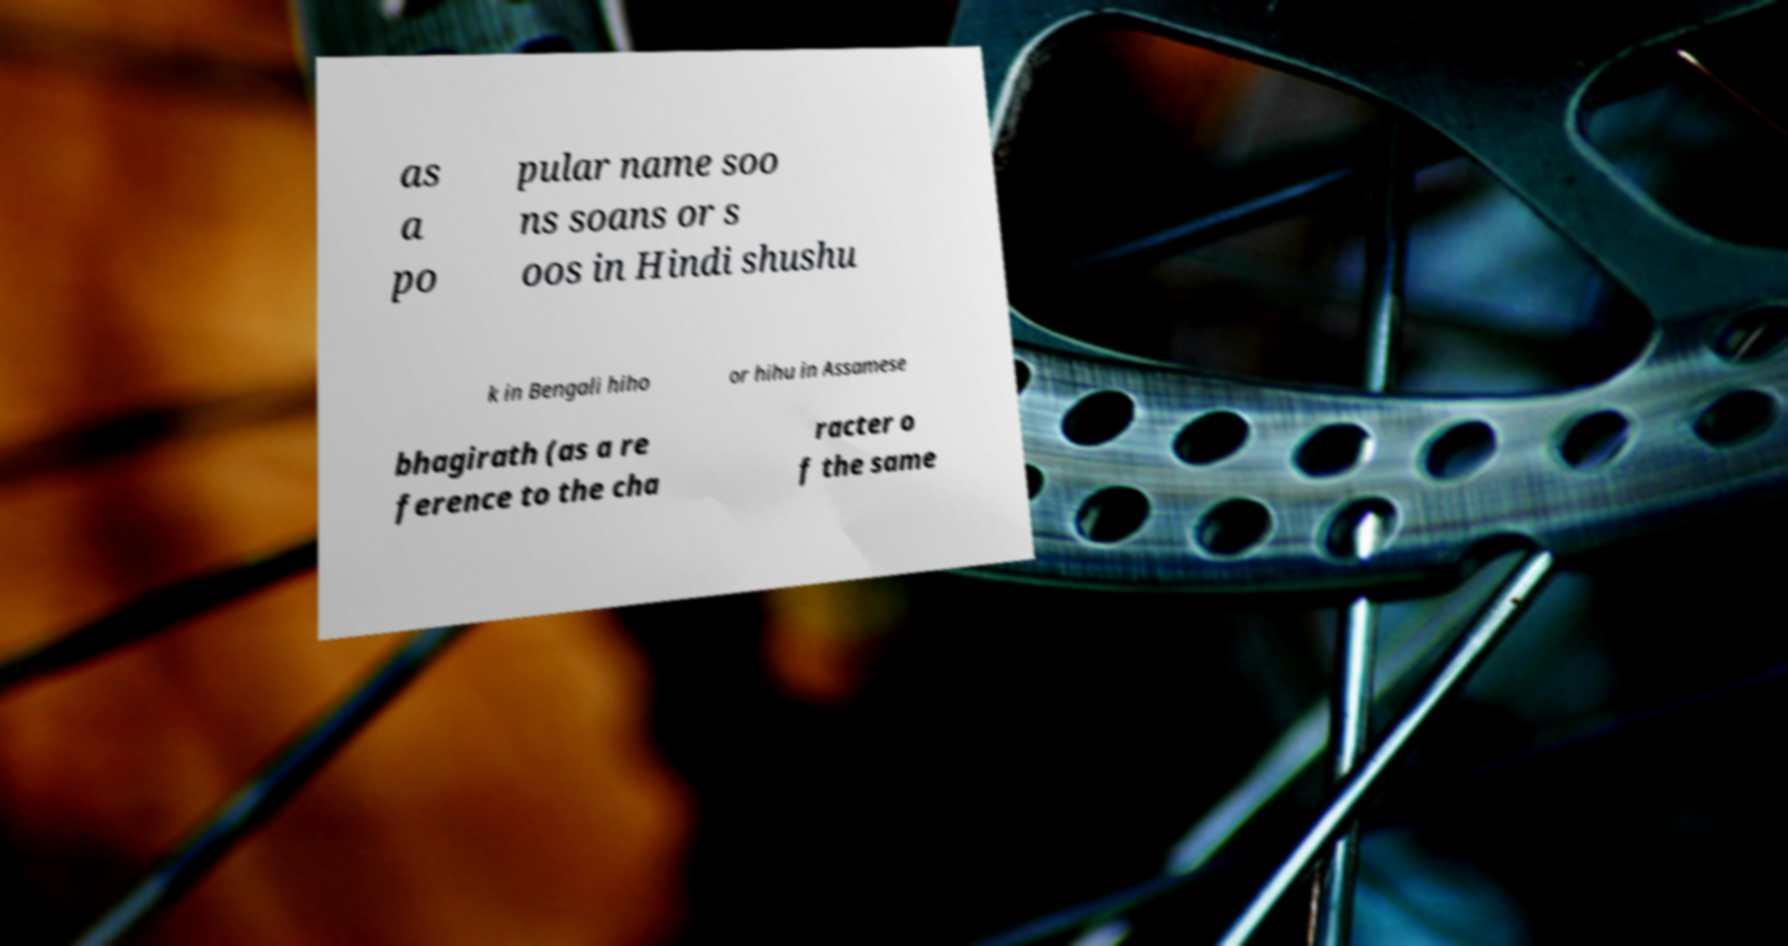Please identify and transcribe the text found in this image. as a po pular name soo ns soans or s oos in Hindi shushu k in Bengali hiho or hihu in Assamese bhagirath (as a re ference to the cha racter o f the same 